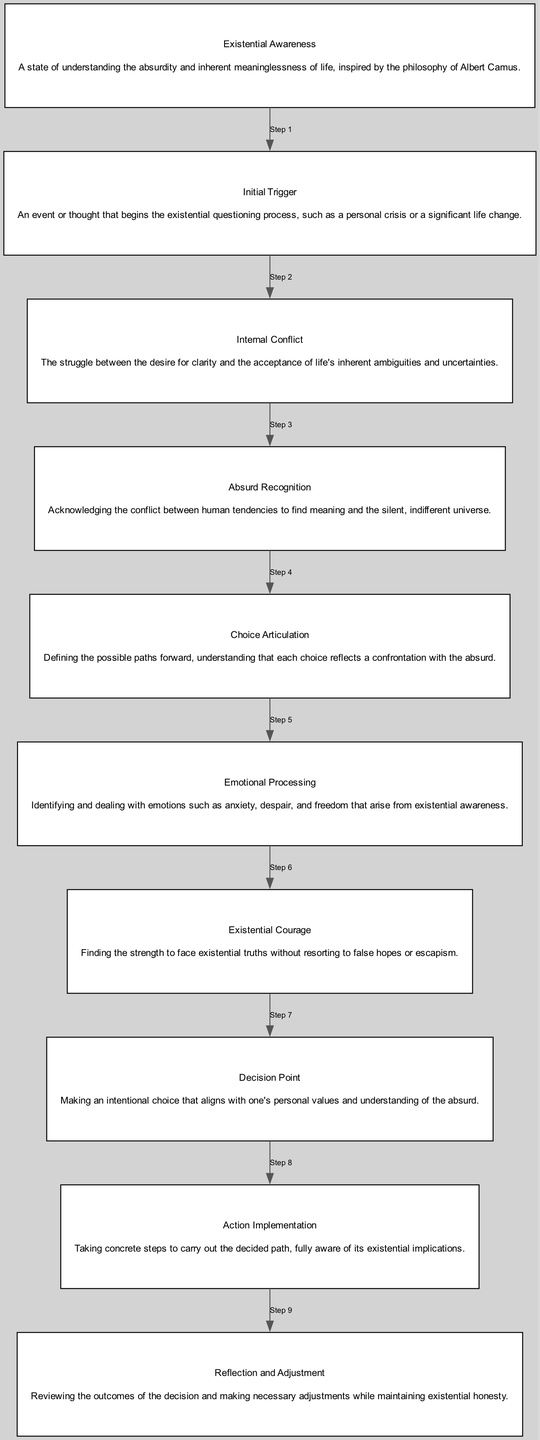How many nodes are in the diagram? The diagram lists ten distinct elements related to the decision-making process, each represented as a node.
Answer: 10 What is the first step in the decision-making process? The flow of the diagram indicates that 'Existential Awareness' is the initial node, which is the starting point of the process.
Answer: Existential Awareness Which element follows 'Absurd Recognition'? Following the sequence in the diagram, the node that comes after 'Absurd Recognition' is 'Choice Articulation'.
Answer: Choice Articulation What does 'Emotional Processing' deal with? According to the description provided in the diagram, 'Emotional Processing' focuses on identifying and addressing various emotional states stemming from existential awareness.
Answer: Anxiety, despair, and freedom How many edges connect the nodes? Since the diagram connects each of the ten nodes consecutively, there will be nine edges connecting them (one less than the number of nodes).
Answer: 9 What is the relationship between 'Initial Trigger' and 'Decision Point'? 'Initial Trigger' leads into 'Internal Conflict', which continues through various steps until the flow eventually reaches 'Decision Point', indicating a pathway through the decision-making process.
Answer: Sequential What is the last step of the diagram? The final node in the structure, which represents the last step of the decision-making process, is 'Reflection and Adjustment'.
Answer: Reflection and Adjustment Describe the transition from 'Internal Conflict' to 'Existential Courage'. After experiencing 'Internal Conflict', which involves grappling with ambiguities, the next step involves developing 'Existential Courage', representing the strength to confront existential truths. This illustrates a progression from struggle to empowerment.
Answer: Strength to face truths What does 'Action Implementation' describe in relation to the decisions made? The diagram specifies that 'Action Implementation' is about executing the chosen path, which is a direct consequence of the 'Decision Point' step.
Answer: Taking concrete steps What does the term 'Absurd Recognition' imply in this context? The term indicates the acknowledgment of the contradiction between human tendencies to seek meaning and the reality of an indifferent universe as described in the diagram.
Answer: Acknowledging the conflict 